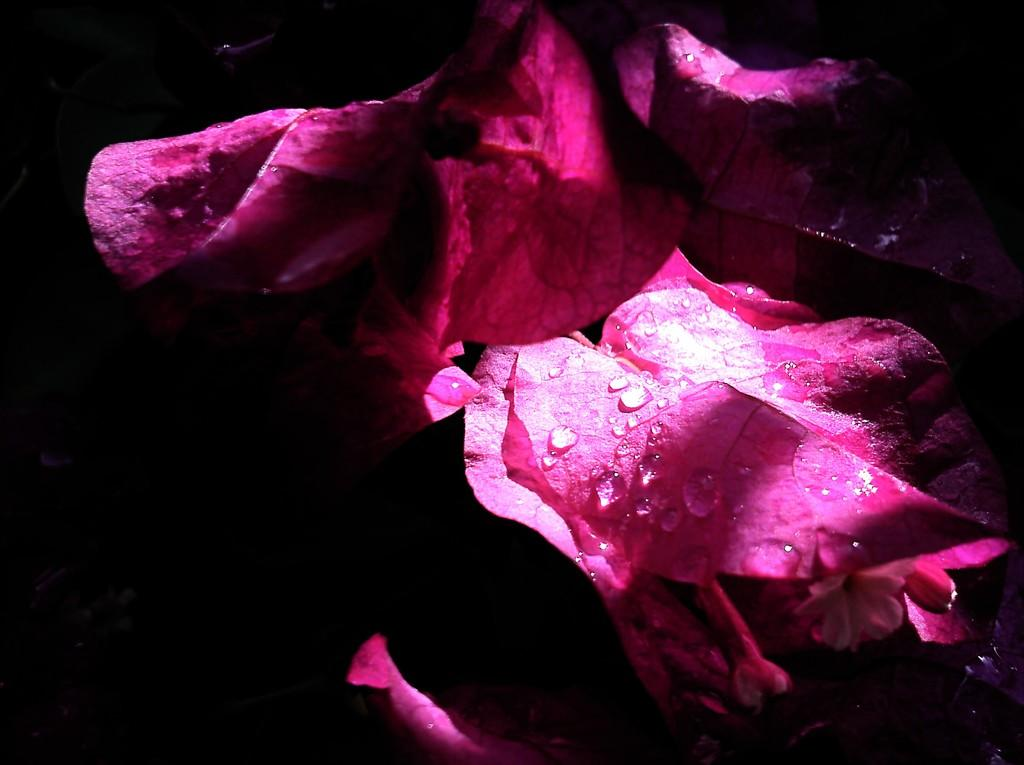What is in the foreground of the image? There are pink petals of flowers in the foreground of the image. What is the condition of the petals? The petals have water droplets on them. How would you describe the overall lighting in the image? The image is dark. What type of cream is being taught in the image? There is no teaching or cream present in the image; it features pink petals of flowers with water droplets in a dark setting. 